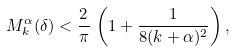<formula> <loc_0><loc_0><loc_500><loc_500>M _ { k } ^ { \alpha } ( \delta ) < \frac { 2 } { \pi } \, \left ( 1 + \frac { 1 } { 8 ( k + \alpha ) ^ { 2 } } \right ) ,</formula> 